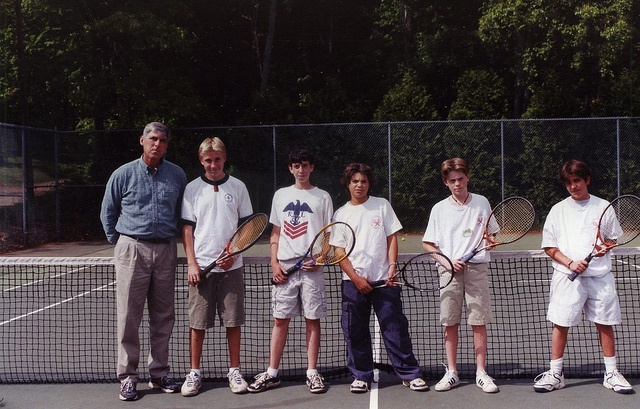Describe the objects in this image and their specific colors. I can see people in black, darkgray, gray, and navy tones, people in black, lightgray, darkgray, and gray tones, people in black, darkgray, lightgray, and maroon tones, people in black, lightgray, darkgray, and gray tones, and people in black, lightgray, darkgray, and maroon tones in this image. 